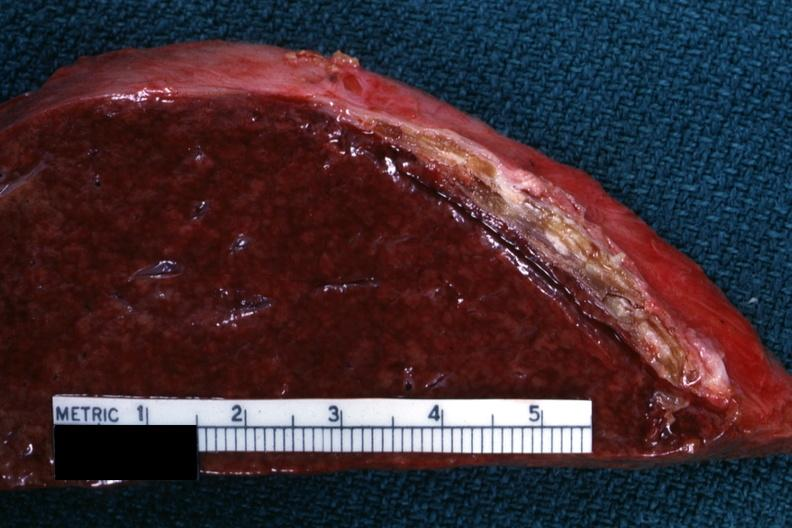s sugar coated present?
Answer the question using a single word or phrase. Yes 